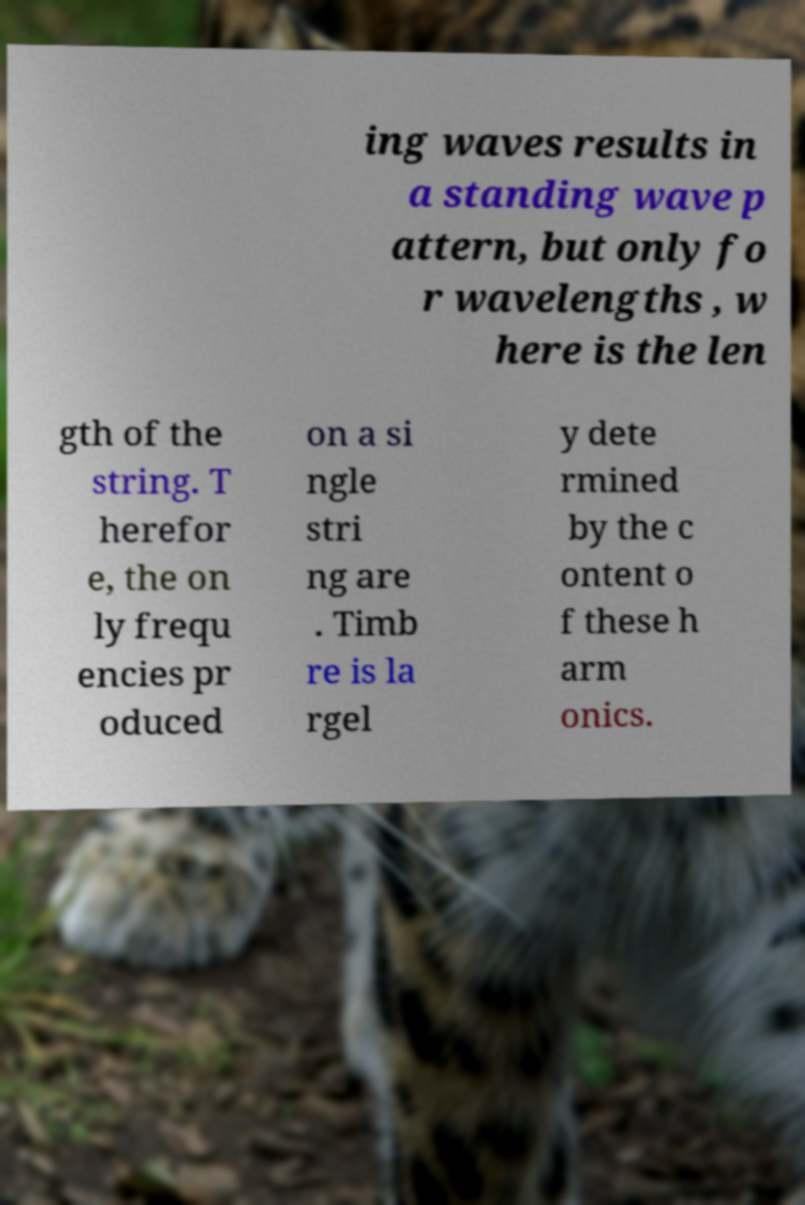Can you read and provide the text displayed in the image?This photo seems to have some interesting text. Can you extract and type it out for me? ing waves results in a standing wave p attern, but only fo r wavelengths , w here is the len gth of the string. T herefor e, the on ly frequ encies pr oduced on a si ngle stri ng are . Timb re is la rgel y dete rmined by the c ontent o f these h arm onics. 